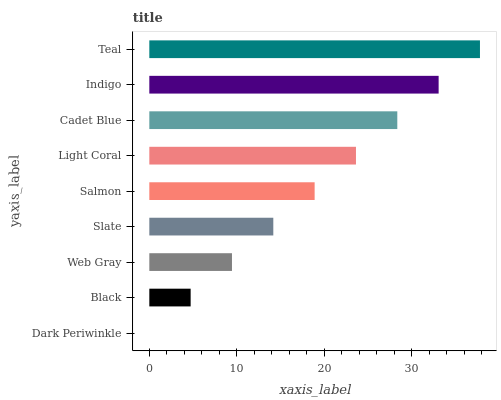Is Dark Periwinkle the minimum?
Answer yes or no. Yes. Is Teal the maximum?
Answer yes or no. Yes. Is Black the minimum?
Answer yes or no. No. Is Black the maximum?
Answer yes or no. No. Is Black greater than Dark Periwinkle?
Answer yes or no. Yes. Is Dark Periwinkle less than Black?
Answer yes or no. Yes. Is Dark Periwinkle greater than Black?
Answer yes or no. No. Is Black less than Dark Periwinkle?
Answer yes or no. No. Is Salmon the high median?
Answer yes or no. Yes. Is Salmon the low median?
Answer yes or no. Yes. Is Web Gray the high median?
Answer yes or no. No. Is Black the low median?
Answer yes or no. No. 